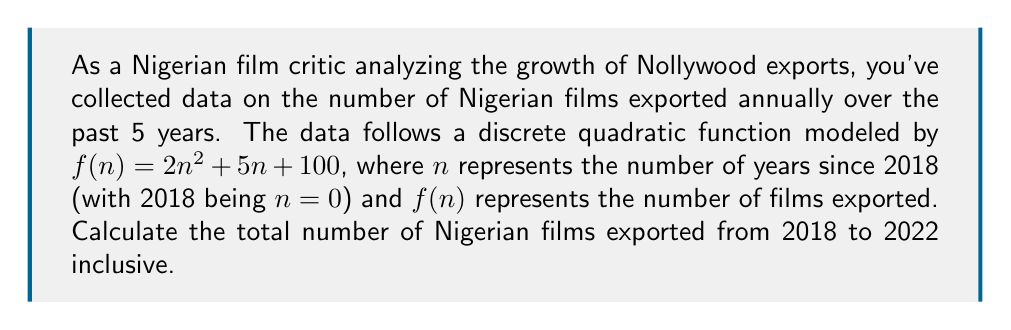Solve this math problem. To solve this problem, we need to follow these steps:

1) First, let's calculate the number of films exported for each year from 2018 to 2022:

   2018 (n=0): $f(0) = 2(0)^2 + 5(0) + 100 = 100$
   2019 (n=1): $f(1) = 2(1)^2 + 5(1) + 100 = 107$
   2020 (n=2): $f(2) = 2(2)^2 + 5(2) + 100 = 118$
   2021 (n=3): $f(3) = 2(3)^2 + 5(3) + 100 = 133$
   2022 (n=4): $f(4) = 2(4)^2 + 5(4) + 100 = 152$

2) Now, we need to sum these values to get the total number of films exported over the 5-year period:

   $\text{Total} = f(0) + f(1) + f(2) + f(3) + f(4)$

3) Substituting the values:

   $\text{Total} = 100 + 107 + 118 + 133 + 152 = 610$

Therefore, the total number of Nigerian films exported from 2018 to 2022 inclusive is 610.
Answer: 610 films 